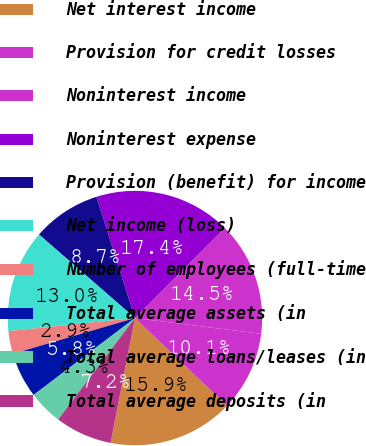Convert chart. <chart><loc_0><loc_0><loc_500><loc_500><pie_chart><fcel>Net interest income<fcel>Provision for credit losses<fcel>Noninterest income<fcel>Noninterest expense<fcel>Provision (benefit) for income<fcel>Net income (loss)<fcel>Number of employees (full-time<fcel>Total average assets (in<fcel>Total average loans/leases (in<fcel>Total average deposits (in<nl><fcel>15.94%<fcel>10.14%<fcel>14.49%<fcel>17.39%<fcel>8.7%<fcel>13.04%<fcel>2.9%<fcel>5.8%<fcel>4.35%<fcel>7.25%<nl></chart> 